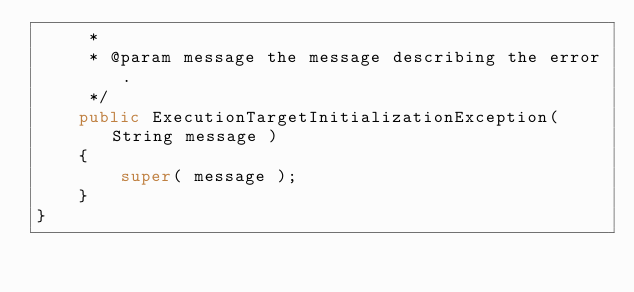Convert code to text. <code><loc_0><loc_0><loc_500><loc_500><_Java_>     *
     * @param message the message describing the error.
     */
    public ExecutionTargetInitializationException( String message )
    {
        super( message );
    }
}
</code> 